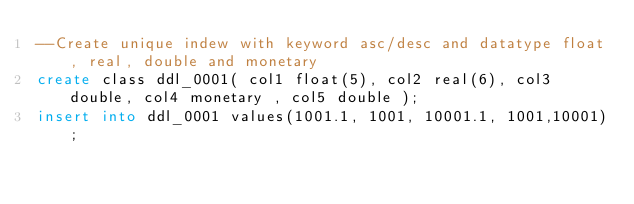<code> <loc_0><loc_0><loc_500><loc_500><_SQL_>--Create unique indew with keyword asc/desc and datatype float, real, double and monetary
create class ddl_0001( col1 float(5), col2 real(6), col3 double, col4 monetary , col5 double );
insert into ddl_0001 values(1001.1, 1001, 10001.1, 1001,10001);</code> 